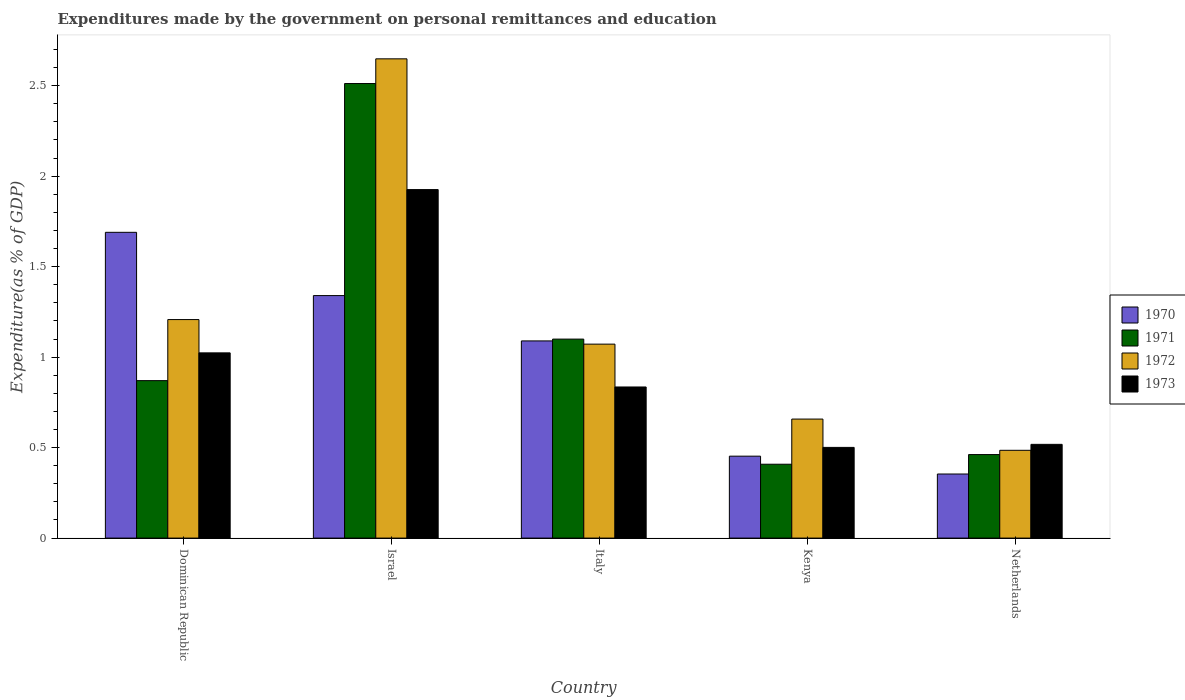How many groups of bars are there?
Ensure brevity in your answer.  5. Are the number of bars on each tick of the X-axis equal?
Make the answer very short. Yes. What is the label of the 2nd group of bars from the left?
Offer a terse response. Israel. In how many cases, is the number of bars for a given country not equal to the number of legend labels?
Keep it short and to the point. 0. What is the expenditures made by the government on personal remittances and education in 1970 in Kenya?
Ensure brevity in your answer.  0.45. Across all countries, what is the maximum expenditures made by the government on personal remittances and education in 1971?
Make the answer very short. 2.51. Across all countries, what is the minimum expenditures made by the government on personal remittances and education in 1972?
Keep it short and to the point. 0.49. In which country was the expenditures made by the government on personal remittances and education in 1970 maximum?
Your response must be concise. Dominican Republic. In which country was the expenditures made by the government on personal remittances and education in 1972 minimum?
Offer a very short reply. Netherlands. What is the total expenditures made by the government on personal remittances and education in 1972 in the graph?
Your response must be concise. 6.07. What is the difference between the expenditures made by the government on personal remittances and education in 1971 in Israel and that in Kenya?
Provide a succinct answer. 2.1. What is the difference between the expenditures made by the government on personal remittances and education in 1970 in Dominican Republic and the expenditures made by the government on personal remittances and education in 1973 in Netherlands?
Offer a terse response. 1.17. What is the average expenditures made by the government on personal remittances and education in 1973 per country?
Offer a terse response. 0.96. What is the difference between the expenditures made by the government on personal remittances and education of/in 1972 and expenditures made by the government on personal remittances and education of/in 1970 in Dominican Republic?
Keep it short and to the point. -0.48. What is the ratio of the expenditures made by the government on personal remittances and education in 1970 in Dominican Republic to that in Kenya?
Give a very brief answer. 3.73. Is the expenditures made by the government on personal remittances and education in 1972 in Dominican Republic less than that in Israel?
Ensure brevity in your answer.  Yes. Is the difference between the expenditures made by the government on personal remittances and education in 1972 in Dominican Republic and Israel greater than the difference between the expenditures made by the government on personal remittances and education in 1970 in Dominican Republic and Israel?
Keep it short and to the point. No. What is the difference between the highest and the second highest expenditures made by the government on personal remittances and education in 1972?
Ensure brevity in your answer.  -1.44. What is the difference between the highest and the lowest expenditures made by the government on personal remittances and education in 1970?
Keep it short and to the point. 1.34. Is it the case that in every country, the sum of the expenditures made by the government on personal remittances and education in 1972 and expenditures made by the government on personal remittances and education in 1970 is greater than the sum of expenditures made by the government on personal remittances and education in 1971 and expenditures made by the government on personal remittances and education in 1973?
Offer a very short reply. No. What does the 3rd bar from the left in Dominican Republic represents?
Offer a very short reply. 1972. What does the 4th bar from the right in Italy represents?
Give a very brief answer. 1970. How many bars are there?
Ensure brevity in your answer.  20. Are all the bars in the graph horizontal?
Offer a very short reply. No. How many countries are there in the graph?
Offer a terse response. 5. Does the graph contain any zero values?
Your answer should be very brief. No. Where does the legend appear in the graph?
Provide a succinct answer. Center right. How many legend labels are there?
Ensure brevity in your answer.  4. What is the title of the graph?
Make the answer very short. Expenditures made by the government on personal remittances and education. What is the label or title of the Y-axis?
Give a very brief answer. Expenditure(as % of GDP). What is the Expenditure(as % of GDP) in 1970 in Dominican Republic?
Provide a short and direct response. 1.69. What is the Expenditure(as % of GDP) of 1971 in Dominican Republic?
Keep it short and to the point. 0.87. What is the Expenditure(as % of GDP) in 1972 in Dominican Republic?
Offer a terse response. 1.21. What is the Expenditure(as % of GDP) in 1973 in Dominican Republic?
Give a very brief answer. 1.02. What is the Expenditure(as % of GDP) in 1970 in Israel?
Give a very brief answer. 1.34. What is the Expenditure(as % of GDP) in 1971 in Israel?
Your answer should be compact. 2.51. What is the Expenditure(as % of GDP) of 1972 in Israel?
Your response must be concise. 2.65. What is the Expenditure(as % of GDP) of 1973 in Israel?
Your answer should be compact. 1.93. What is the Expenditure(as % of GDP) in 1970 in Italy?
Offer a terse response. 1.09. What is the Expenditure(as % of GDP) of 1971 in Italy?
Offer a terse response. 1.1. What is the Expenditure(as % of GDP) in 1972 in Italy?
Your answer should be compact. 1.07. What is the Expenditure(as % of GDP) in 1973 in Italy?
Keep it short and to the point. 0.84. What is the Expenditure(as % of GDP) of 1970 in Kenya?
Provide a short and direct response. 0.45. What is the Expenditure(as % of GDP) in 1971 in Kenya?
Make the answer very short. 0.41. What is the Expenditure(as % of GDP) in 1972 in Kenya?
Give a very brief answer. 0.66. What is the Expenditure(as % of GDP) of 1973 in Kenya?
Provide a short and direct response. 0.5. What is the Expenditure(as % of GDP) in 1970 in Netherlands?
Your response must be concise. 0.35. What is the Expenditure(as % of GDP) of 1971 in Netherlands?
Your answer should be compact. 0.46. What is the Expenditure(as % of GDP) in 1972 in Netherlands?
Keep it short and to the point. 0.49. What is the Expenditure(as % of GDP) in 1973 in Netherlands?
Provide a short and direct response. 0.52. Across all countries, what is the maximum Expenditure(as % of GDP) of 1970?
Offer a very short reply. 1.69. Across all countries, what is the maximum Expenditure(as % of GDP) in 1971?
Offer a terse response. 2.51. Across all countries, what is the maximum Expenditure(as % of GDP) of 1972?
Keep it short and to the point. 2.65. Across all countries, what is the maximum Expenditure(as % of GDP) in 1973?
Your answer should be compact. 1.93. Across all countries, what is the minimum Expenditure(as % of GDP) of 1970?
Your answer should be compact. 0.35. Across all countries, what is the minimum Expenditure(as % of GDP) of 1971?
Offer a very short reply. 0.41. Across all countries, what is the minimum Expenditure(as % of GDP) in 1972?
Your response must be concise. 0.49. Across all countries, what is the minimum Expenditure(as % of GDP) in 1973?
Your answer should be very brief. 0.5. What is the total Expenditure(as % of GDP) of 1970 in the graph?
Make the answer very short. 4.93. What is the total Expenditure(as % of GDP) in 1971 in the graph?
Offer a terse response. 5.35. What is the total Expenditure(as % of GDP) of 1972 in the graph?
Provide a short and direct response. 6.07. What is the total Expenditure(as % of GDP) in 1973 in the graph?
Offer a terse response. 4.8. What is the difference between the Expenditure(as % of GDP) in 1970 in Dominican Republic and that in Israel?
Make the answer very short. 0.35. What is the difference between the Expenditure(as % of GDP) in 1971 in Dominican Republic and that in Israel?
Your response must be concise. -1.64. What is the difference between the Expenditure(as % of GDP) in 1972 in Dominican Republic and that in Israel?
Provide a succinct answer. -1.44. What is the difference between the Expenditure(as % of GDP) in 1973 in Dominican Republic and that in Israel?
Your answer should be very brief. -0.9. What is the difference between the Expenditure(as % of GDP) of 1970 in Dominican Republic and that in Italy?
Provide a short and direct response. 0.6. What is the difference between the Expenditure(as % of GDP) of 1971 in Dominican Republic and that in Italy?
Keep it short and to the point. -0.23. What is the difference between the Expenditure(as % of GDP) of 1972 in Dominican Republic and that in Italy?
Provide a short and direct response. 0.14. What is the difference between the Expenditure(as % of GDP) in 1973 in Dominican Republic and that in Italy?
Your response must be concise. 0.19. What is the difference between the Expenditure(as % of GDP) in 1970 in Dominican Republic and that in Kenya?
Give a very brief answer. 1.24. What is the difference between the Expenditure(as % of GDP) in 1971 in Dominican Republic and that in Kenya?
Your answer should be compact. 0.46. What is the difference between the Expenditure(as % of GDP) of 1972 in Dominican Republic and that in Kenya?
Ensure brevity in your answer.  0.55. What is the difference between the Expenditure(as % of GDP) of 1973 in Dominican Republic and that in Kenya?
Give a very brief answer. 0.52. What is the difference between the Expenditure(as % of GDP) in 1970 in Dominican Republic and that in Netherlands?
Provide a short and direct response. 1.34. What is the difference between the Expenditure(as % of GDP) of 1971 in Dominican Republic and that in Netherlands?
Ensure brevity in your answer.  0.41. What is the difference between the Expenditure(as % of GDP) in 1972 in Dominican Republic and that in Netherlands?
Keep it short and to the point. 0.72. What is the difference between the Expenditure(as % of GDP) in 1973 in Dominican Republic and that in Netherlands?
Your answer should be compact. 0.51. What is the difference between the Expenditure(as % of GDP) in 1970 in Israel and that in Italy?
Offer a very short reply. 0.25. What is the difference between the Expenditure(as % of GDP) of 1971 in Israel and that in Italy?
Ensure brevity in your answer.  1.41. What is the difference between the Expenditure(as % of GDP) of 1972 in Israel and that in Italy?
Make the answer very short. 1.58. What is the difference between the Expenditure(as % of GDP) of 1973 in Israel and that in Italy?
Provide a short and direct response. 1.09. What is the difference between the Expenditure(as % of GDP) of 1970 in Israel and that in Kenya?
Keep it short and to the point. 0.89. What is the difference between the Expenditure(as % of GDP) in 1971 in Israel and that in Kenya?
Make the answer very short. 2.1. What is the difference between the Expenditure(as % of GDP) in 1972 in Israel and that in Kenya?
Offer a terse response. 1.99. What is the difference between the Expenditure(as % of GDP) in 1973 in Israel and that in Kenya?
Make the answer very short. 1.42. What is the difference between the Expenditure(as % of GDP) in 1970 in Israel and that in Netherlands?
Provide a succinct answer. 0.99. What is the difference between the Expenditure(as % of GDP) in 1971 in Israel and that in Netherlands?
Make the answer very short. 2.05. What is the difference between the Expenditure(as % of GDP) of 1972 in Israel and that in Netherlands?
Your answer should be very brief. 2.16. What is the difference between the Expenditure(as % of GDP) of 1973 in Israel and that in Netherlands?
Make the answer very short. 1.41. What is the difference between the Expenditure(as % of GDP) of 1970 in Italy and that in Kenya?
Your answer should be very brief. 0.64. What is the difference between the Expenditure(as % of GDP) of 1971 in Italy and that in Kenya?
Your answer should be compact. 0.69. What is the difference between the Expenditure(as % of GDP) in 1972 in Italy and that in Kenya?
Offer a terse response. 0.41. What is the difference between the Expenditure(as % of GDP) in 1973 in Italy and that in Kenya?
Keep it short and to the point. 0.33. What is the difference between the Expenditure(as % of GDP) in 1970 in Italy and that in Netherlands?
Offer a very short reply. 0.74. What is the difference between the Expenditure(as % of GDP) in 1971 in Italy and that in Netherlands?
Offer a terse response. 0.64. What is the difference between the Expenditure(as % of GDP) in 1972 in Italy and that in Netherlands?
Give a very brief answer. 0.59. What is the difference between the Expenditure(as % of GDP) of 1973 in Italy and that in Netherlands?
Give a very brief answer. 0.32. What is the difference between the Expenditure(as % of GDP) of 1970 in Kenya and that in Netherlands?
Offer a terse response. 0.1. What is the difference between the Expenditure(as % of GDP) of 1971 in Kenya and that in Netherlands?
Give a very brief answer. -0.05. What is the difference between the Expenditure(as % of GDP) of 1972 in Kenya and that in Netherlands?
Your answer should be compact. 0.17. What is the difference between the Expenditure(as % of GDP) in 1973 in Kenya and that in Netherlands?
Offer a very short reply. -0.02. What is the difference between the Expenditure(as % of GDP) of 1970 in Dominican Republic and the Expenditure(as % of GDP) of 1971 in Israel?
Provide a short and direct response. -0.82. What is the difference between the Expenditure(as % of GDP) of 1970 in Dominican Republic and the Expenditure(as % of GDP) of 1972 in Israel?
Your answer should be very brief. -0.96. What is the difference between the Expenditure(as % of GDP) of 1970 in Dominican Republic and the Expenditure(as % of GDP) of 1973 in Israel?
Ensure brevity in your answer.  -0.24. What is the difference between the Expenditure(as % of GDP) of 1971 in Dominican Republic and the Expenditure(as % of GDP) of 1972 in Israel?
Your answer should be very brief. -1.78. What is the difference between the Expenditure(as % of GDP) in 1971 in Dominican Republic and the Expenditure(as % of GDP) in 1973 in Israel?
Your response must be concise. -1.06. What is the difference between the Expenditure(as % of GDP) in 1972 in Dominican Republic and the Expenditure(as % of GDP) in 1973 in Israel?
Your response must be concise. -0.72. What is the difference between the Expenditure(as % of GDP) of 1970 in Dominican Republic and the Expenditure(as % of GDP) of 1971 in Italy?
Your answer should be compact. 0.59. What is the difference between the Expenditure(as % of GDP) of 1970 in Dominican Republic and the Expenditure(as % of GDP) of 1972 in Italy?
Make the answer very short. 0.62. What is the difference between the Expenditure(as % of GDP) in 1970 in Dominican Republic and the Expenditure(as % of GDP) in 1973 in Italy?
Your answer should be very brief. 0.85. What is the difference between the Expenditure(as % of GDP) of 1971 in Dominican Republic and the Expenditure(as % of GDP) of 1972 in Italy?
Provide a succinct answer. -0.2. What is the difference between the Expenditure(as % of GDP) in 1971 in Dominican Republic and the Expenditure(as % of GDP) in 1973 in Italy?
Provide a succinct answer. 0.04. What is the difference between the Expenditure(as % of GDP) of 1972 in Dominican Republic and the Expenditure(as % of GDP) of 1973 in Italy?
Offer a terse response. 0.37. What is the difference between the Expenditure(as % of GDP) of 1970 in Dominican Republic and the Expenditure(as % of GDP) of 1971 in Kenya?
Provide a short and direct response. 1.28. What is the difference between the Expenditure(as % of GDP) of 1970 in Dominican Republic and the Expenditure(as % of GDP) of 1972 in Kenya?
Offer a very short reply. 1.03. What is the difference between the Expenditure(as % of GDP) of 1970 in Dominican Republic and the Expenditure(as % of GDP) of 1973 in Kenya?
Offer a terse response. 1.19. What is the difference between the Expenditure(as % of GDP) in 1971 in Dominican Republic and the Expenditure(as % of GDP) in 1972 in Kenya?
Your answer should be compact. 0.21. What is the difference between the Expenditure(as % of GDP) in 1971 in Dominican Republic and the Expenditure(as % of GDP) in 1973 in Kenya?
Your answer should be compact. 0.37. What is the difference between the Expenditure(as % of GDP) of 1972 in Dominican Republic and the Expenditure(as % of GDP) of 1973 in Kenya?
Ensure brevity in your answer.  0.71. What is the difference between the Expenditure(as % of GDP) in 1970 in Dominican Republic and the Expenditure(as % of GDP) in 1971 in Netherlands?
Provide a succinct answer. 1.23. What is the difference between the Expenditure(as % of GDP) of 1970 in Dominican Republic and the Expenditure(as % of GDP) of 1972 in Netherlands?
Make the answer very short. 1.2. What is the difference between the Expenditure(as % of GDP) in 1970 in Dominican Republic and the Expenditure(as % of GDP) in 1973 in Netherlands?
Offer a very short reply. 1.17. What is the difference between the Expenditure(as % of GDP) of 1971 in Dominican Republic and the Expenditure(as % of GDP) of 1972 in Netherlands?
Keep it short and to the point. 0.39. What is the difference between the Expenditure(as % of GDP) in 1971 in Dominican Republic and the Expenditure(as % of GDP) in 1973 in Netherlands?
Offer a terse response. 0.35. What is the difference between the Expenditure(as % of GDP) of 1972 in Dominican Republic and the Expenditure(as % of GDP) of 1973 in Netherlands?
Give a very brief answer. 0.69. What is the difference between the Expenditure(as % of GDP) of 1970 in Israel and the Expenditure(as % of GDP) of 1971 in Italy?
Ensure brevity in your answer.  0.24. What is the difference between the Expenditure(as % of GDP) in 1970 in Israel and the Expenditure(as % of GDP) in 1972 in Italy?
Offer a very short reply. 0.27. What is the difference between the Expenditure(as % of GDP) of 1970 in Israel and the Expenditure(as % of GDP) of 1973 in Italy?
Give a very brief answer. 0.51. What is the difference between the Expenditure(as % of GDP) in 1971 in Israel and the Expenditure(as % of GDP) in 1972 in Italy?
Your answer should be very brief. 1.44. What is the difference between the Expenditure(as % of GDP) in 1971 in Israel and the Expenditure(as % of GDP) in 1973 in Italy?
Offer a very short reply. 1.68. What is the difference between the Expenditure(as % of GDP) in 1972 in Israel and the Expenditure(as % of GDP) in 1973 in Italy?
Keep it short and to the point. 1.81. What is the difference between the Expenditure(as % of GDP) in 1970 in Israel and the Expenditure(as % of GDP) in 1971 in Kenya?
Ensure brevity in your answer.  0.93. What is the difference between the Expenditure(as % of GDP) in 1970 in Israel and the Expenditure(as % of GDP) in 1972 in Kenya?
Your response must be concise. 0.68. What is the difference between the Expenditure(as % of GDP) of 1970 in Israel and the Expenditure(as % of GDP) of 1973 in Kenya?
Give a very brief answer. 0.84. What is the difference between the Expenditure(as % of GDP) in 1971 in Israel and the Expenditure(as % of GDP) in 1972 in Kenya?
Your response must be concise. 1.85. What is the difference between the Expenditure(as % of GDP) of 1971 in Israel and the Expenditure(as % of GDP) of 1973 in Kenya?
Provide a short and direct response. 2.01. What is the difference between the Expenditure(as % of GDP) in 1972 in Israel and the Expenditure(as % of GDP) in 1973 in Kenya?
Your response must be concise. 2.15. What is the difference between the Expenditure(as % of GDP) of 1970 in Israel and the Expenditure(as % of GDP) of 1971 in Netherlands?
Provide a short and direct response. 0.88. What is the difference between the Expenditure(as % of GDP) of 1970 in Israel and the Expenditure(as % of GDP) of 1972 in Netherlands?
Your response must be concise. 0.85. What is the difference between the Expenditure(as % of GDP) of 1970 in Israel and the Expenditure(as % of GDP) of 1973 in Netherlands?
Your response must be concise. 0.82. What is the difference between the Expenditure(as % of GDP) in 1971 in Israel and the Expenditure(as % of GDP) in 1972 in Netherlands?
Keep it short and to the point. 2.03. What is the difference between the Expenditure(as % of GDP) in 1971 in Israel and the Expenditure(as % of GDP) in 1973 in Netherlands?
Offer a very short reply. 1.99. What is the difference between the Expenditure(as % of GDP) of 1972 in Israel and the Expenditure(as % of GDP) of 1973 in Netherlands?
Your response must be concise. 2.13. What is the difference between the Expenditure(as % of GDP) of 1970 in Italy and the Expenditure(as % of GDP) of 1971 in Kenya?
Keep it short and to the point. 0.68. What is the difference between the Expenditure(as % of GDP) of 1970 in Italy and the Expenditure(as % of GDP) of 1972 in Kenya?
Ensure brevity in your answer.  0.43. What is the difference between the Expenditure(as % of GDP) in 1970 in Italy and the Expenditure(as % of GDP) in 1973 in Kenya?
Provide a short and direct response. 0.59. What is the difference between the Expenditure(as % of GDP) in 1971 in Italy and the Expenditure(as % of GDP) in 1972 in Kenya?
Keep it short and to the point. 0.44. What is the difference between the Expenditure(as % of GDP) of 1971 in Italy and the Expenditure(as % of GDP) of 1973 in Kenya?
Ensure brevity in your answer.  0.6. What is the difference between the Expenditure(as % of GDP) of 1972 in Italy and the Expenditure(as % of GDP) of 1973 in Kenya?
Offer a very short reply. 0.57. What is the difference between the Expenditure(as % of GDP) in 1970 in Italy and the Expenditure(as % of GDP) in 1971 in Netherlands?
Keep it short and to the point. 0.63. What is the difference between the Expenditure(as % of GDP) of 1970 in Italy and the Expenditure(as % of GDP) of 1972 in Netherlands?
Keep it short and to the point. 0.6. What is the difference between the Expenditure(as % of GDP) of 1970 in Italy and the Expenditure(as % of GDP) of 1973 in Netherlands?
Keep it short and to the point. 0.57. What is the difference between the Expenditure(as % of GDP) of 1971 in Italy and the Expenditure(as % of GDP) of 1972 in Netherlands?
Your response must be concise. 0.61. What is the difference between the Expenditure(as % of GDP) of 1971 in Italy and the Expenditure(as % of GDP) of 1973 in Netherlands?
Make the answer very short. 0.58. What is the difference between the Expenditure(as % of GDP) of 1972 in Italy and the Expenditure(as % of GDP) of 1973 in Netherlands?
Give a very brief answer. 0.55. What is the difference between the Expenditure(as % of GDP) in 1970 in Kenya and the Expenditure(as % of GDP) in 1971 in Netherlands?
Offer a very short reply. -0.01. What is the difference between the Expenditure(as % of GDP) of 1970 in Kenya and the Expenditure(as % of GDP) of 1972 in Netherlands?
Your answer should be compact. -0.03. What is the difference between the Expenditure(as % of GDP) of 1970 in Kenya and the Expenditure(as % of GDP) of 1973 in Netherlands?
Offer a terse response. -0.07. What is the difference between the Expenditure(as % of GDP) of 1971 in Kenya and the Expenditure(as % of GDP) of 1972 in Netherlands?
Your answer should be compact. -0.08. What is the difference between the Expenditure(as % of GDP) in 1971 in Kenya and the Expenditure(as % of GDP) in 1973 in Netherlands?
Provide a short and direct response. -0.11. What is the difference between the Expenditure(as % of GDP) of 1972 in Kenya and the Expenditure(as % of GDP) of 1973 in Netherlands?
Keep it short and to the point. 0.14. What is the average Expenditure(as % of GDP) of 1971 per country?
Your answer should be compact. 1.07. What is the average Expenditure(as % of GDP) of 1972 per country?
Your response must be concise. 1.21. What is the average Expenditure(as % of GDP) of 1973 per country?
Your response must be concise. 0.96. What is the difference between the Expenditure(as % of GDP) of 1970 and Expenditure(as % of GDP) of 1971 in Dominican Republic?
Ensure brevity in your answer.  0.82. What is the difference between the Expenditure(as % of GDP) of 1970 and Expenditure(as % of GDP) of 1972 in Dominican Republic?
Your answer should be compact. 0.48. What is the difference between the Expenditure(as % of GDP) in 1970 and Expenditure(as % of GDP) in 1973 in Dominican Republic?
Provide a succinct answer. 0.67. What is the difference between the Expenditure(as % of GDP) in 1971 and Expenditure(as % of GDP) in 1972 in Dominican Republic?
Keep it short and to the point. -0.34. What is the difference between the Expenditure(as % of GDP) of 1971 and Expenditure(as % of GDP) of 1973 in Dominican Republic?
Give a very brief answer. -0.15. What is the difference between the Expenditure(as % of GDP) in 1972 and Expenditure(as % of GDP) in 1973 in Dominican Republic?
Offer a very short reply. 0.18. What is the difference between the Expenditure(as % of GDP) in 1970 and Expenditure(as % of GDP) in 1971 in Israel?
Ensure brevity in your answer.  -1.17. What is the difference between the Expenditure(as % of GDP) of 1970 and Expenditure(as % of GDP) of 1972 in Israel?
Give a very brief answer. -1.31. What is the difference between the Expenditure(as % of GDP) in 1970 and Expenditure(as % of GDP) in 1973 in Israel?
Provide a succinct answer. -0.59. What is the difference between the Expenditure(as % of GDP) of 1971 and Expenditure(as % of GDP) of 1972 in Israel?
Provide a short and direct response. -0.14. What is the difference between the Expenditure(as % of GDP) in 1971 and Expenditure(as % of GDP) in 1973 in Israel?
Your answer should be very brief. 0.59. What is the difference between the Expenditure(as % of GDP) in 1972 and Expenditure(as % of GDP) in 1973 in Israel?
Provide a succinct answer. 0.72. What is the difference between the Expenditure(as % of GDP) of 1970 and Expenditure(as % of GDP) of 1971 in Italy?
Keep it short and to the point. -0.01. What is the difference between the Expenditure(as % of GDP) of 1970 and Expenditure(as % of GDP) of 1972 in Italy?
Your answer should be compact. 0.02. What is the difference between the Expenditure(as % of GDP) in 1970 and Expenditure(as % of GDP) in 1973 in Italy?
Your answer should be very brief. 0.25. What is the difference between the Expenditure(as % of GDP) in 1971 and Expenditure(as % of GDP) in 1972 in Italy?
Keep it short and to the point. 0.03. What is the difference between the Expenditure(as % of GDP) of 1971 and Expenditure(as % of GDP) of 1973 in Italy?
Offer a very short reply. 0.26. What is the difference between the Expenditure(as % of GDP) of 1972 and Expenditure(as % of GDP) of 1973 in Italy?
Offer a very short reply. 0.24. What is the difference between the Expenditure(as % of GDP) in 1970 and Expenditure(as % of GDP) in 1971 in Kenya?
Your answer should be compact. 0.04. What is the difference between the Expenditure(as % of GDP) of 1970 and Expenditure(as % of GDP) of 1972 in Kenya?
Provide a short and direct response. -0.2. What is the difference between the Expenditure(as % of GDP) in 1970 and Expenditure(as % of GDP) in 1973 in Kenya?
Offer a very short reply. -0.05. What is the difference between the Expenditure(as % of GDP) of 1971 and Expenditure(as % of GDP) of 1972 in Kenya?
Offer a terse response. -0.25. What is the difference between the Expenditure(as % of GDP) of 1971 and Expenditure(as % of GDP) of 1973 in Kenya?
Your response must be concise. -0.09. What is the difference between the Expenditure(as % of GDP) in 1972 and Expenditure(as % of GDP) in 1973 in Kenya?
Your answer should be very brief. 0.16. What is the difference between the Expenditure(as % of GDP) in 1970 and Expenditure(as % of GDP) in 1971 in Netherlands?
Ensure brevity in your answer.  -0.11. What is the difference between the Expenditure(as % of GDP) in 1970 and Expenditure(as % of GDP) in 1972 in Netherlands?
Provide a short and direct response. -0.13. What is the difference between the Expenditure(as % of GDP) in 1970 and Expenditure(as % of GDP) in 1973 in Netherlands?
Your response must be concise. -0.16. What is the difference between the Expenditure(as % of GDP) in 1971 and Expenditure(as % of GDP) in 1972 in Netherlands?
Offer a very short reply. -0.02. What is the difference between the Expenditure(as % of GDP) of 1971 and Expenditure(as % of GDP) of 1973 in Netherlands?
Your answer should be very brief. -0.06. What is the difference between the Expenditure(as % of GDP) of 1972 and Expenditure(as % of GDP) of 1973 in Netherlands?
Provide a succinct answer. -0.03. What is the ratio of the Expenditure(as % of GDP) in 1970 in Dominican Republic to that in Israel?
Make the answer very short. 1.26. What is the ratio of the Expenditure(as % of GDP) in 1971 in Dominican Republic to that in Israel?
Offer a terse response. 0.35. What is the ratio of the Expenditure(as % of GDP) in 1972 in Dominican Republic to that in Israel?
Your answer should be compact. 0.46. What is the ratio of the Expenditure(as % of GDP) of 1973 in Dominican Republic to that in Israel?
Your answer should be very brief. 0.53. What is the ratio of the Expenditure(as % of GDP) of 1970 in Dominican Republic to that in Italy?
Ensure brevity in your answer.  1.55. What is the ratio of the Expenditure(as % of GDP) in 1971 in Dominican Republic to that in Italy?
Offer a very short reply. 0.79. What is the ratio of the Expenditure(as % of GDP) in 1972 in Dominican Republic to that in Italy?
Give a very brief answer. 1.13. What is the ratio of the Expenditure(as % of GDP) of 1973 in Dominican Republic to that in Italy?
Give a very brief answer. 1.23. What is the ratio of the Expenditure(as % of GDP) of 1970 in Dominican Republic to that in Kenya?
Your answer should be very brief. 3.73. What is the ratio of the Expenditure(as % of GDP) in 1971 in Dominican Republic to that in Kenya?
Keep it short and to the point. 2.13. What is the ratio of the Expenditure(as % of GDP) of 1972 in Dominican Republic to that in Kenya?
Offer a very short reply. 1.84. What is the ratio of the Expenditure(as % of GDP) of 1973 in Dominican Republic to that in Kenya?
Make the answer very short. 2.04. What is the ratio of the Expenditure(as % of GDP) in 1970 in Dominican Republic to that in Netherlands?
Provide a succinct answer. 4.77. What is the ratio of the Expenditure(as % of GDP) of 1971 in Dominican Republic to that in Netherlands?
Keep it short and to the point. 1.89. What is the ratio of the Expenditure(as % of GDP) of 1972 in Dominican Republic to that in Netherlands?
Keep it short and to the point. 2.49. What is the ratio of the Expenditure(as % of GDP) in 1973 in Dominican Republic to that in Netherlands?
Your response must be concise. 1.98. What is the ratio of the Expenditure(as % of GDP) of 1970 in Israel to that in Italy?
Provide a succinct answer. 1.23. What is the ratio of the Expenditure(as % of GDP) in 1971 in Israel to that in Italy?
Keep it short and to the point. 2.28. What is the ratio of the Expenditure(as % of GDP) of 1972 in Israel to that in Italy?
Provide a succinct answer. 2.47. What is the ratio of the Expenditure(as % of GDP) of 1973 in Israel to that in Italy?
Give a very brief answer. 2.31. What is the ratio of the Expenditure(as % of GDP) in 1970 in Israel to that in Kenya?
Make the answer very short. 2.96. What is the ratio of the Expenditure(as % of GDP) in 1971 in Israel to that in Kenya?
Provide a short and direct response. 6.15. What is the ratio of the Expenditure(as % of GDP) of 1972 in Israel to that in Kenya?
Give a very brief answer. 4.03. What is the ratio of the Expenditure(as % of GDP) of 1973 in Israel to that in Kenya?
Ensure brevity in your answer.  3.84. What is the ratio of the Expenditure(as % of GDP) of 1970 in Israel to that in Netherlands?
Offer a terse response. 3.78. What is the ratio of the Expenditure(as % of GDP) of 1971 in Israel to that in Netherlands?
Offer a very short reply. 5.44. What is the ratio of the Expenditure(as % of GDP) of 1972 in Israel to that in Netherlands?
Ensure brevity in your answer.  5.46. What is the ratio of the Expenditure(as % of GDP) of 1973 in Israel to that in Netherlands?
Offer a very short reply. 3.72. What is the ratio of the Expenditure(as % of GDP) in 1970 in Italy to that in Kenya?
Your response must be concise. 2.41. What is the ratio of the Expenditure(as % of GDP) in 1971 in Italy to that in Kenya?
Provide a short and direct response. 2.69. What is the ratio of the Expenditure(as % of GDP) in 1972 in Italy to that in Kenya?
Your answer should be very brief. 1.63. What is the ratio of the Expenditure(as % of GDP) in 1973 in Italy to that in Kenya?
Give a very brief answer. 1.67. What is the ratio of the Expenditure(as % of GDP) of 1970 in Italy to that in Netherlands?
Make the answer very short. 3.08. What is the ratio of the Expenditure(as % of GDP) in 1971 in Italy to that in Netherlands?
Offer a terse response. 2.38. What is the ratio of the Expenditure(as % of GDP) of 1972 in Italy to that in Netherlands?
Provide a succinct answer. 2.21. What is the ratio of the Expenditure(as % of GDP) in 1973 in Italy to that in Netherlands?
Provide a short and direct response. 1.61. What is the ratio of the Expenditure(as % of GDP) in 1970 in Kenya to that in Netherlands?
Your answer should be compact. 1.28. What is the ratio of the Expenditure(as % of GDP) of 1971 in Kenya to that in Netherlands?
Provide a short and direct response. 0.88. What is the ratio of the Expenditure(as % of GDP) of 1972 in Kenya to that in Netherlands?
Your answer should be very brief. 1.36. What is the ratio of the Expenditure(as % of GDP) in 1973 in Kenya to that in Netherlands?
Keep it short and to the point. 0.97. What is the difference between the highest and the second highest Expenditure(as % of GDP) in 1970?
Ensure brevity in your answer.  0.35. What is the difference between the highest and the second highest Expenditure(as % of GDP) of 1971?
Ensure brevity in your answer.  1.41. What is the difference between the highest and the second highest Expenditure(as % of GDP) in 1972?
Your answer should be very brief. 1.44. What is the difference between the highest and the second highest Expenditure(as % of GDP) in 1973?
Your response must be concise. 0.9. What is the difference between the highest and the lowest Expenditure(as % of GDP) of 1970?
Keep it short and to the point. 1.34. What is the difference between the highest and the lowest Expenditure(as % of GDP) of 1971?
Offer a very short reply. 2.1. What is the difference between the highest and the lowest Expenditure(as % of GDP) of 1972?
Make the answer very short. 2.16. What is the difference between the highest and the lowest Expenditure(as % of GDP) in 1973?
Your answer should be compact. 1.42. 